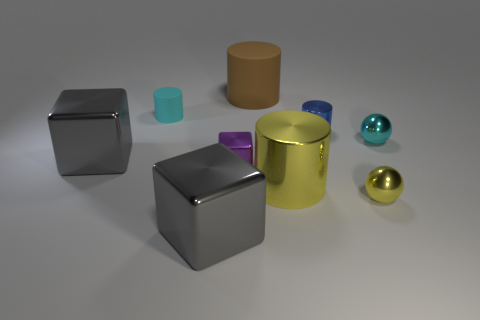How many cubes are the same color as the small matte cylinder?
Your response must be concise. 0. Is the number of small shiny balls greater than the number of yellow balls?
Keep it short and to the point. Yes. There is a cylinder that is both to the right of the big brown rubber object and on the left side of the small blue object; what size is it?
Offer a terse response. Large. Is the material of the tiny cylinder on the left side of the blue metallic cylinder the same as the large cylinder behind the yellow shiny cylinder?
Provide a succinct answer. Yes. There is a purple object that is the same size as the blue shiny object; what is its shape?
Your answer should be very brief. Cube. Are there fewer big matte objects than big gray shiny objects?
Provide a short and direct response. Yes. Are there any tiny metallic spheres that are in front of the yellow metallic object on the right side of the blue cylinder?
Make the answer very short. No. Are there any large metallic cubes to the right of the gray metal block that is behind the small metal sphere to the left of the tiny cyan shiny object?
Offer a terse response. Yes. Does the gray object in front of the tiny yellow sphere have the same shape as the small cyan object that is behind the cyan metal sphere?
Provide a succinct answer. No. The other object that is the same material as the big brown thing is what color?
Give a very brief answer. Cyan. 